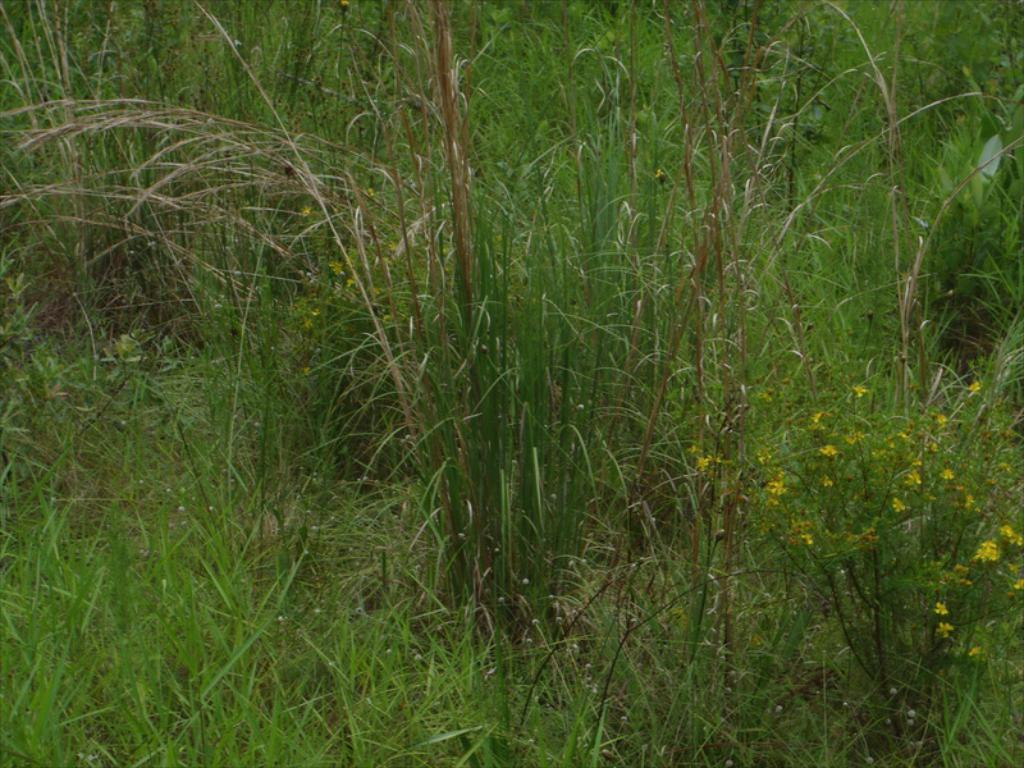What type of flowers can be seen in the image? There are yellow flowers in the image. What can be seen in the background of the image? The background of the image includes grass. How many legs can be seen on the flowers in the image? Flowers do not have legs, so this question cannot be answered based on the image. 